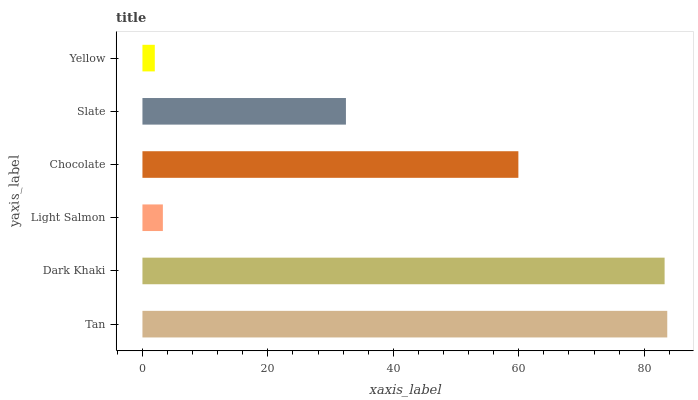Is Yellow the minimum?
Answer yes or no. Yes. Is Tan the maximum?
Answer yes or no. Yes. Is Dark Khaki the minimum?
Answer yes or no. No. Is Dark Khaki the maximum?
Answer yes or no. No. Is Tan greater than Dark Khaki?
Answer yes or no. Yes. Is Dark Khaki less than Tan?
Answer yes or no. Yes. Is Dark Khaki greater than Tan?
Answer yes or no. No. Is Tan less than Dark Khaki?
Answer yes or no. No. Is Chocolate the high median?
Answer yes or no. Yes. Is Slate the low median?
Answer yes or no. Yes. Is Dark Khaki the high median?
Answer yes or no. No. Is Dark Khaki the low median?
Answer yes or no. No. 